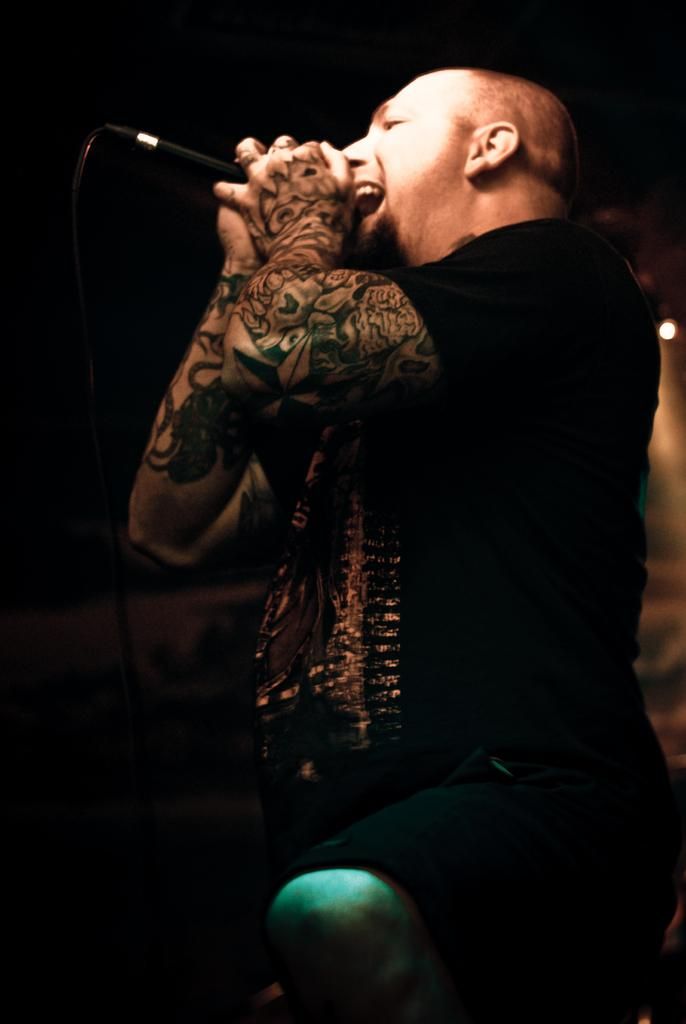What is the main subject of the image? There is a man in the image. What is the man holding in the image? The man is holding a mic. What activity is the man engaged in? The man appears to be singing. What type of cushion is the man sitting on in the image? There is no cushion present in the image, as the man is not sitting down. 